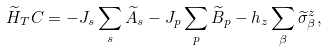Convert formula to latex. <formula><loc_0><loc_0><loc_500><loc_500>\widetilde { H } _ { T } C = - J _ { s } \sum _ { s } \widetilde { A } _ { s } - J _ { p } \sum _ { p } \widetilde { B } _ { p } - h _ { z } \sum _ { \beta } \widetilde { \sigma } _ { \beta } ^ { z } ,</formula> 